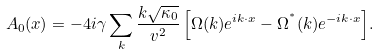Convert formula to latex. <formula><loc_0><loc_0><loc_500><loc_500>A _ { 0 } ( { x } ) = - 4 i \gamma \sum _ { k } { \frac { k \sqrt { \kappa _ { 0 } } } { v ^ { 2 } } \left [ \Omega ( { k } ) e ^ { i { k \cdot x } } - \Omega ^ { ^ { * } } ( { k } ) e ^ { - i { k \cdot x } } \right ] } .</formula> 